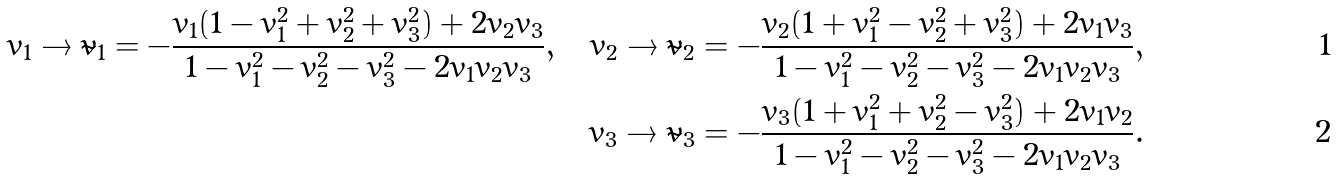Convert formula to latex. <formula><loc_0><loc_0><loc_500><loc_500>v _ { 1 } \to { \tilde { v } } _ { 1 } = - \frac { v _ { 1 } ( 1 - v _ { 1 } ^ { 2 } + v _ { 2 } ^ { 2 } + v _ { 3 } ^ { 2 } ) + 2 v _ { 2 } v _ { 3 } } { 1 - v _ { 1 } ^ { 2 } - v _ { 2 } ^ { 2 } - v _ { 3 } ^ { 2 } - 2 v _ { 1 } v _ { 2 } v _ { 3 } } , \quad v _ { 2 } \to { \tilde { v } } _ { 2 } = - \frac { v _ { 2 } ( 1 + v _ { 1 } ^ { 2 } - v _ { 2 } ^ { 2 } + v _ { 3 } ^ { 2 } ) + 2 v _ { 1 } v _ { 3 } } { 1 - v _ { 1 } ^ { 2 } - v _ { 2 } ^ { 2 } - v _ { 3 } ^ { 2 } - 2 v _ { 1 } v _ { 2 } v _ { 3 } } , \\ v _ { 3 } \to { \tilde { v } } _ { 3 } = - \frac { v _ { 3 } ( 1 + v _ { 1 } ^ { 2 } + v _ { 2 } ^ { 2 } - v _ { 3 } ^ { 2 } ) + 2 v _ { 1 } v _ { 2 } } { 1 - v _ { 1 } ^ { 2 } - v _ { 2 } ^ { 2 } - v _ { 3 } ^ { 2 } - 2 v _ { 1 } v _ { 2 } v _ { 3 } } .</formula> 